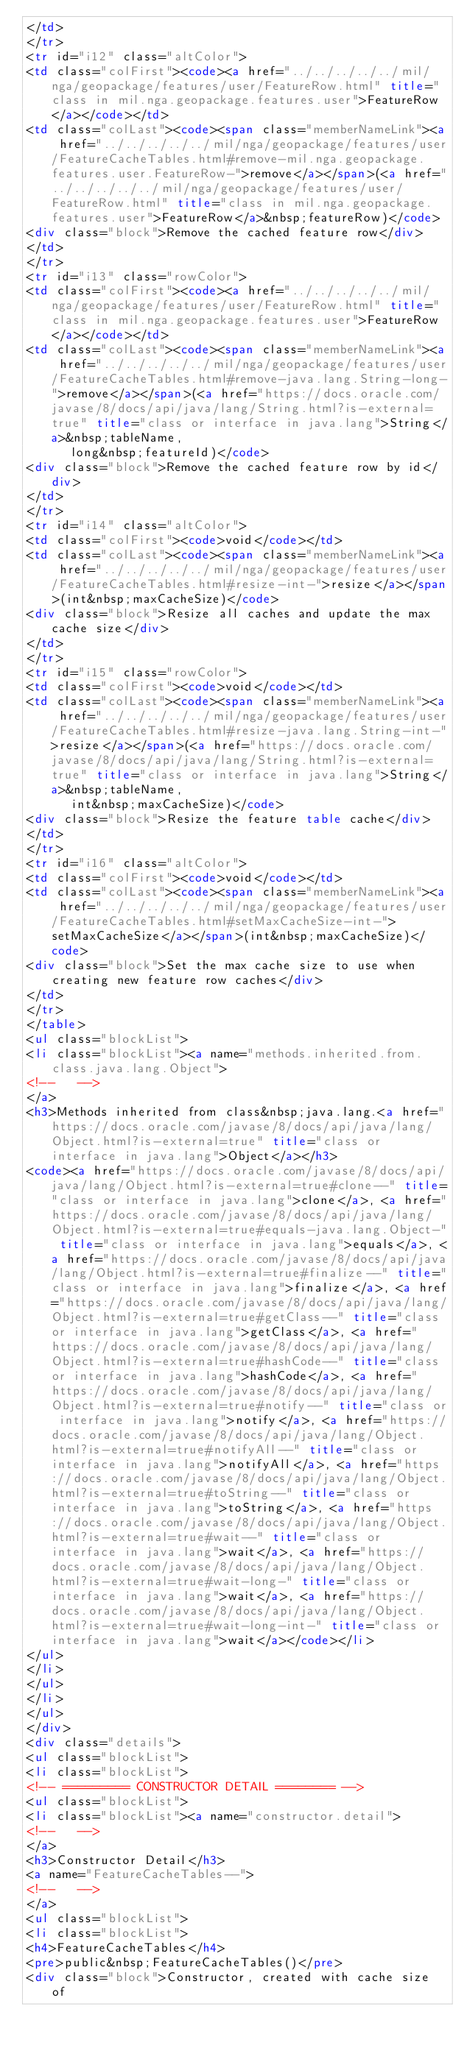Convert code to text. <code><loc_0><loc_0><loc_500><loc_500><_HTML_></td>
</tr>
<tr id="i12" class="altColor">
<td class="colFirst"><code><a href="../../../../../mil/nga/geopackage/features/user/FeatureRow.html" title="class in mil.nga.geopackage.features.user">FeatureRow</a></code></td>
<td class="colLast"><code><span class="memberNameLink"><a href="../../../../../mil/nga/geopackage/features/user/FeatureCacheTables.html#remove-mil.nga.geopackage.features.user.FeatureRow-">remove</a></span>(<a href="../../../../../mil/nga/geopackage/features/user/FeatureRow.html" title="class in mil.nga.geopackage.features.user">FeatureRow</a>&nbsp;featureRow)</code>
<div class="block">Remove the cached feature row</div>
</td>
</tr>
<tr id="i13" class="rowColor">
<td class="colFirst"><code><a href="../../../../../mil/nga/geopackage/features/user/FeatureRow.html" title="class in mil.nga.geopackage.features.user">FeatureRow</a></code></td>
<td class="colLast"><code><span class="memberNameLink"><a href="../../../../../mil/nga/geopackage/features/user/FeatureCacheTables.html#remove-java.lang.String-long-">remove</a></span>(<a href="https://docs.oracle.com/javase/8/docs/api/java/lang/String.html?is-external=true" title="class or interface in java.lang">String</a>&nbsp;tableName,
      long&nbsp;featureId)</code>
<div class="block">Remove the cached feature row by id</div>
</td>
</tr>
<tr id="i14" class="altColor">
<td class="colFirst"><code>void</code></td>
<td class="colLast"><code><span class="memberNameLink"><a href="../../../../../mil/nga/geopackage/features/user/FeatureCacheTables.html#resize-int-">resize</a></span>(int&nbsp;maxCacheSize)</code>
<div class="block">Resize all caches and update the max cache size</div>
</td>
</tr>
<tr id="i15" class="rowColor">
<td class="colFirst"><code>void</code></td>
<td class="colLast"><code><span class="memberNameLink"><a href="../../../../../mil/nga/geopackage/features/user/FeatureCacheTables.html#resize-java.lang.String-int-">resize</a></span>(<a href="https://docs.oracle.com/javase/8/docs/api/java/lang/String.html?is-external=true" title="class or interface in java.lang">String</a>&nbsp;tableName,
      int&nbsp;maxCacheSize)</code>
<div class="block">Resize the feature table cache</div>
</td>
</tr>
<tr id="i16" class="altColor">
<td class="colFirst"><code>void</code></td>
<td class="colLast"><code><span class="memberNameLink"><a href="../../../../../mil/nga/geopackage/features/user/FeatureCacheTables.html#setMaxCacheSize-int-">setMaxCacheSize</a></span>(int&nbsp;maxCacheSize)</code>
<div class="block">Set the max cache size to use when creating new feature row caches</div>
</td>
</tr>
</table>
<ul class="blockList">
<li class="blockList"><a name="methods.inherited.from.class.java.lang.Object">
<!--   -->
</a>
<h3>Methods inherited from class&nbsp;java.lang.<a href="https://docs.oracle.com/javase/8/docs/api/java/lang/Object.html?is-external=true" title="class or interface in java.lang">Object</a></h3>
<code><a href="https://docs.oracle.com/javase/8/docs/api/java/lang/Object.html?is-external=true#clone--" title="class or interface in java.lang">clone</a>, <a href="https://docs.oracle.com/javase/8/docs/api/java/lang/Object.html?is-external=true#equals-java.lang.Object-" title="class or interface in java.lang">equals</a>, <a href="https://docs.oracle.com/javase/8/docs/api/java/lang/Object.html?is-external=true#finalize--" title="class or interface in java.lang">finalize</a>, <a href="https://docs.oracle.com/javase/8/docs/api/java/lang/Object.html?is-external=true#getClass--" title="class or interface in java.lang">getClass</a>, <a href="https://docs.oracle.com/javase/8/docs/api/java/lang/Object.html?is-external=true#hashCode--" title="class or interface in java.lang">hashCode</a>, <a href="https://docs.oracle.com/javase/8/docs/api/java/lang/Object.html?is-external=true#notify--" title="class or interface in java.lang">notify</a>, <a href="https://docs.oracle.com/javase/8/docs/api/java/lang/Object.html?is-external=true#notifyAll--" title="class or interface in java.lang">notifyAll</a>, <a href="https://docs.oracle.com/javase/8/docs/api/java/lang/Object.html?is-external=true#toString--" title="class or interface in java.lang">toString</a>, <a href="https://docs.oracle.com/javase/8/docs/api/java/lang/Object.html?is-external=true#wait--" title="class or interface in java.lang">wait</a>, <a href="https://docs.oracle.com/javase/8/docs/api/java/lang/Object.html?is-external=true#wait-long-" title="class or interface in java.lang">wait</a>, <a href="https://docs.oracle.com/javase/8/docs/api/java/lang/Object.html?is-external=true#wait-long-int-" title="class or interface in java.lang">wait</a></code></li>
</ul>
</li>
</ul>
</li>
</ul>
</div>
<div class="details">
<ul class="blockList">
<li class="blockList">
<!-- ========= CONSTRUCTOR DETAIL ======== -->
<ul class="blockList">
<li class="blockList"><a name="constructor.detail">
<!--   -->
</a>
<h3>Constructor Detail</h3>
<a name="FeatureCacheTables--">
<!--   -->
</a>
<ul class="blockList">
<li class="blockList">
<h4>FeatureCacheTables</h4>
<pre>public&nbsp;FeatureCacheTables()</pre>
<div class="block">Constructor, created with cache size of</code> 